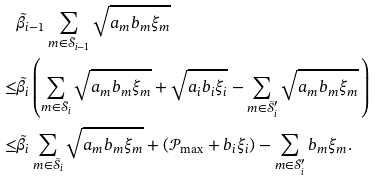Convert formula to latex. <formula><loc_0><loc_0><loc_500><loc_500>& \tilde { \beta } _ { i - 1 } \sum _ { m \in \tilde { \mathcal { S } } _ { i - 1 } } \sqrt { a _ { m } b _ { m } \xi _ { m } } \\ \leq & \tilde { \beta } _ { i } \left ( \sum _ { m \in \tilde { \mathcal { S } } _ { i } } \sqrt { a _ { m } b _ { m } \xi _ { m } } + \sqrt { a _ { i } b _ { i } \xi _ { i } } - \sum _ { m \in \tilde { \mathcal { S } } ^ { \prime } _ { i } } \sqrt { a _ { m } b _ { m } \xi _ { m } } \, \right ) \\ \leq & \tilde { \beta } _ { i } \sum _ { m \in \tilde { \mathcal { S } } _ { i } } \sqrt { a _ { m } b _ { m } \xi _ { m } } + ( \mathcal { P } _ { \max } + b _ { i } \xi _ { i } ) - \sum _ { m \in \tilde { \mathcal { S } } ^ { \prime } _ { i } } b _ { m } \xi _ { m } .</formula> 